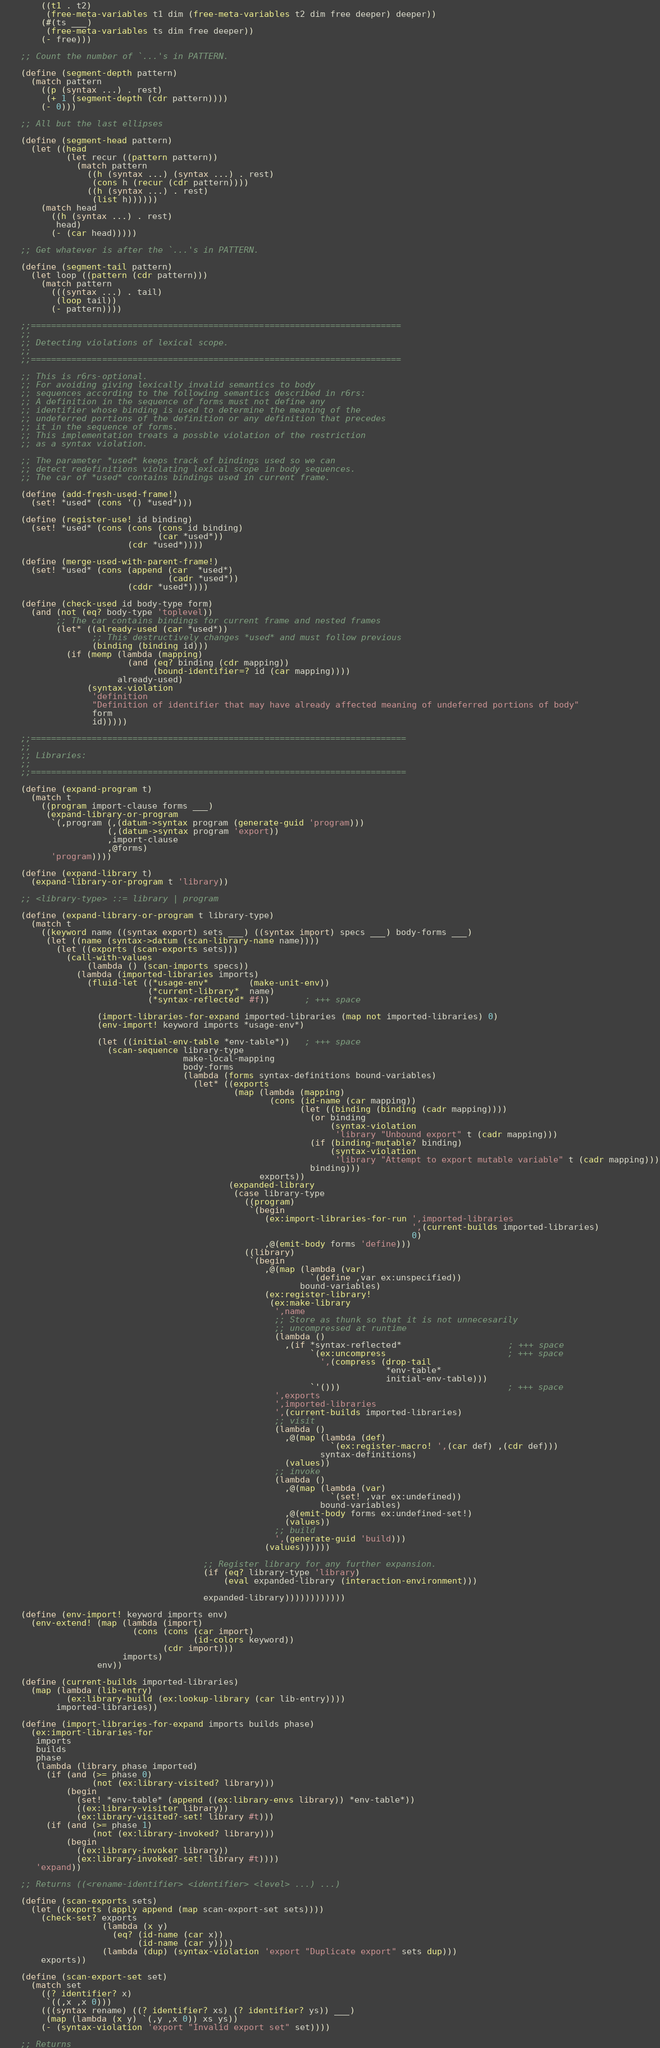<code> <loc_0><loc_0><loc_500><loc_500><_Scheme_>        ((t1 . t2)
         (free-meta-variables t1 dim (free-meta-variables t2 dim free deeper) deeper))
        (#(ts ___) 
         (free-meta-variables ts dim free deeper))
        (- free)))
 
    ;; Count the number of `...'s in PATTERN.

    (define (segment-depth pattern)
      (match pattern
        ((p (syntax ...) . rest)
         (+ 1 (segment-depth (cdr pattern))))
        (- 0)))
      
    ;; All but the last ellipses
    
    (define (segment-head pattern)
      (let ((head
             (let recur ((pattern pattern))
               (match pattern
                 ((h (syntax ...) (syntax ...) . rest)
                  (cons h (recur (cdr pattern))))
                 ((h (syntax ...) . rest)
                  (list h))))))
        (match head 
          ((h (syntax ...) . rest)
           head)
          (- (car head)))))   

    ;; Get whatever is after the `...'s in PATTERN.

    (define (segment-tail pattern)
      (let loop ((pattern (cdr pattern)))
        (match pattern
          (((syntax ...) . tail)
           (loop tail))
          (- pattern))))

    ;;=========================================================================
    ;;
    ;; Detecting violations of lexical scope.
    ;;
    ;;=========================================================================

    ;; This is r6rs-optional.
    ;; For avoiding giving lexically invalid semantics to body
    ;; sequences according to the following semantics described in r6rs:
    ;; A definition in the sequence of forms must not define any
    ;; identifier whose binding is used to determine the meaning of the
    ;; undeferred portions of the definition or any definition that precedes
    ;; it in the sequence of forms.
    ;; This implementation treats a possble violation of the restriction
    ;; as a syntax violation.

    ;; The parameter *used* keeps track of bindings used so we can
    ;; detect redefinitions violating lexical scope in body sequences.
    ;; The car of *used* contains bindings used in current frame.

    (define (add-fresh-used-frame!)
      (set! *used* (cons '() *used*)))

    (define (register-use! id binding)
      (set! *used* (cons (cons (cons id binding)
                               (car *used*))
                         (cdr *used*))))

    (define (merge-used-with-parent-frame!)
      (set! *used* (cons (append (car  *used*)
                                 (cadr *used*))
                         (cddr *used*))))

    (define (check-used id body-type form)
      (and (not (eq? body-type 'toplevel))
           ;; The car contains bindings for current frame and nested frames
           (let* ((already-used (car *used*))
                  ;; This destructively changes *used* and must follow previous
                  (binding (binding id)))
             (if (memp (lambda (mapping)
                         (and (eq? binding (cdr mapping))
                              (bound-identifier=? id (car mapping))))
                       already-used)
                 (syntax-violation
                  'definition
                  "Definition of identifier that may have already affected meaning of undeferred portions of body"
                  form
                  id)))))

    ;;==========================================================================
    ;;
    ;; Libraries:
    ;;
    ;;==========================================================================

    (define (expand-program t)
      (match t
        ((program import-clause forms ___)
         (expand-library-or-program
          `(,program (,(datum->syntax program (generate-guid 'program)))
                     (,(datum->syntax program 'export))
                     ,import-clause
                     ,@forms)
          'program))))

    (define (expand-library t)
      (expand-library-or-program t 'library))

    ;; <library-type> ::= library | program

    (define (expand-library-or-program t library-type)
      (match t
        ((keyword name ((syntax export) sets ___) ((syntax import) specs ___) body-forms ___)
         (let ((name (syntax->datum (scan-library-name name))))
           (let ((exports (scan-exports sets)))
             (call-with-values
                 (lambda () (scan-imports specs))
               (lambda (imported-libraries imports)
                 (fluid-let ((*usage-env*        (make-unit-env))
                             (*current-library*  name)
                             (*syntax-reflected* #f))       ; +++ space

                   (import-libraries-for-expand imported-libraries (map not imported-libraries) 0)
                   (env-import! keyword imports *usage-env*)

                   (let ((initial-env-table *env-table*))   ; +++ space
                     (scan-sequence library-type
                                    make-local-mapping
                                    body-forms
                                    (lambda (forms syntax-definitions bound-variables)
                                      (let* ((exports
                                              (map (lambda (mapping)
                                                     (cons (id-name (car mapping))
                                                           (let ((binding (binding (cadr mapping))))
                                                             (or binding
                                                                 (syntax-violation
                                                                  'library "Unbound export" t (cadr mapping)))
                                                             (if (binding-mutable? binding)
                                                                 (syntax-violation
                                                                  'library "Attempt to export mutable variable" t (cadr mapping)))
                                                             binding)))
                                                   exports))
                                             (expanded-library
                                              (case library-type
                                                ((program)
                                                 `(begin
                                                    (ex:import-libraries-for-run ',imported-libraries
                                                                                 ',(current-builds imported-libraries)
                                                                                 0)
                                                    ,@(emit-body forms 'define)))
                                                ((library)
                                                 `(begin
                                                    ,@(map (lambda (var)
                                                             `(define ,var ex:unspecified))
                                                           bound-variables)
                                                    (ex:register-library!
                                                     (ex:make-library
                                                      ',name
                                                      ;; Store as thunk so that it is not unnecesarily
                                                      ;; uncompressed at runtime
                                                      (lambda ()
                                                        ,(if *syntax-reflected*                     ; +++ space
                                                             `(ex:uncompress                        ; +++ space
                                                               ',(compress (drop-tail
                                                                            *env-table*
                                                                            initial-env-table)))
                                                             `'()))                                 ; +++ space
                                                      ',exports
                                                      ',imported-libraries
                                                      ',(current-builds imported-libraries)
                                                      ;; visit
                                                      (lambda ()
                                                        ,@(map (lambda (def)
                                                                 `(ex:register-macro! ',(car def) ,(cdr def)))
                                                               syntax-definitions)
                                                        (values))
                                                      ;; invoke
                                                      (lambda ()
                                                        ,@(map (lambda (var)
                                                                 `(set! ,var ex:undefined))
                                                               bound-variables)
                                                        ,@(emit-body forms ex:undefined-set!)
                                                        (values))
                                                      ;; build
                                                      ',(generate-guid 'build)))
                                                    (values))))))

                                        ;; Register library for any further expansion.
                                        (if (eq? library-type 'library)
                                            (eval expanded-library (interaction-environment)))

                                        expanded-library))))))))))))

    (define (env-import! keyword imports env)
      (env-extend! (map (lambda (import)
                          (cons (cons (car import)
                                      (id-colors keyword))
                                (cdr import)))
                        imports)
                   env))

    (define (current-builds imported-libraries)
      (map (lambda (lib-entry)
             (ex:library-build (ex:lookup-library (car lib-entry))))
           imported-libraries))

    (define (import-libraries-for-expand imports builds phase)
      (ex:import-libraries-for
       imports
       builds
       phase
       (lambda (library phase imported)
         (if (and (>= phase 0)
                  (not (ex:library-visited? library)))
             (begin
               (set! *env-table* (append ((ex:library-envs library)) *env-table*))
               ((ex:library-visiter library))
               (ex:library-visited?-set! library #t)))
         (if (and (>= phase 1)
                  (not (ex:library-invoked? library)))
             (begin 
               ((ex:library-invoker library))
               (ex:library-invoked?-set! library #t))))
       'expand))

    ;; Returns ((<rename-identifier> <identifier> <level> ...) ...)

    (define (scan-exports sets)
      (let ((exports (apply append (map scan-export-set sets))))
        (check-set? exports
                    (lambda (x y)
                      (eq? (id-name (car x))
                           (id-name (car y))))
                    (lambda (dup) (syntax-violation 'export "Duplicate export" sets dup)))
        exports))

    (define (scan-export-set set)
      (match set
        ((? identifier? x)
         `((,x ,x 0)))
        (((syntax rename) ((? identifier? xs) (? identifier? ys)) ___)
         (map (lambda (x y) `(,y ,x 0)) xs ys))
        (- (syntax-violation 'export "Invalid export set" set))))

    ;; Returns</code> 